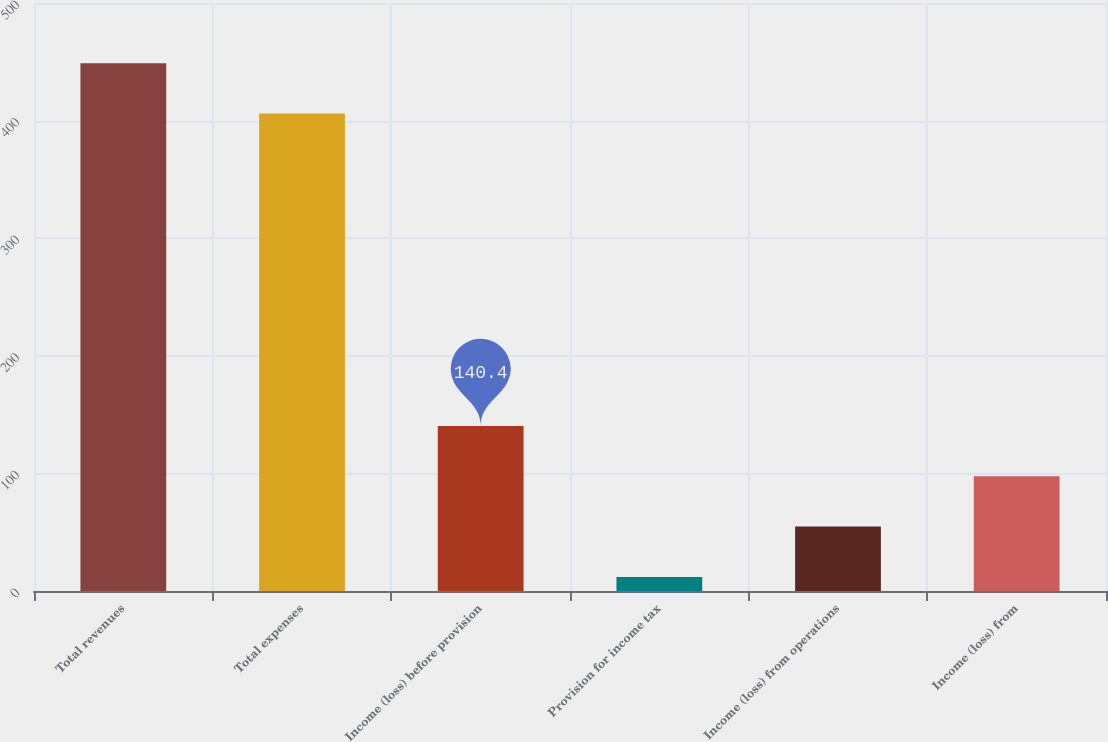Convert chart to OTSL. <chart><loc_0><loc_0><loc_500><loc_500><bar_chart><fcel>Total revenues<fcel>Total expenses<fcel>Income (loss) before provision<fcel>Provision for income tax<fcel>Income (loss) from operations<fcel>Income (loss) from<nl><fcel>448.8<fcel>406<fcel>140.4<fcel>12<fcel>54.8<fcel>97.6<nl></chart> 